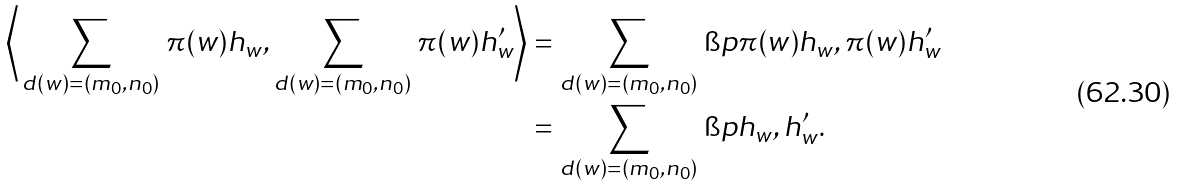Convert formula to latex. <formula><loc_0><loc_0><loc_500><loc_500>\left \langle \, \sum _ { d ( w ) = ( m _ { 0 } , n _ { 0 } ) } \, \pi ( w ) h _ { w } , \sum _ { d ( w ) = ( m _ { 0 } , n _ { 0 } ) } \, \pi ( w ) h ^ { \prime } _ { w } \right \rangle & = \sum _ { d ( w ) = ( m _ { 0 } , n _ { 0 } ) } \, \i p { \pi ( w ) h _ { w } , \pi ( w ) h ^ { \prime } _ { w } } \\ & = \sum _ { d ( w ) = ( m _ { 0 } , n _ { 0 } ) } \, \i p { h _ { w } , h ^ { \prime } _ { w } } .</formula> 